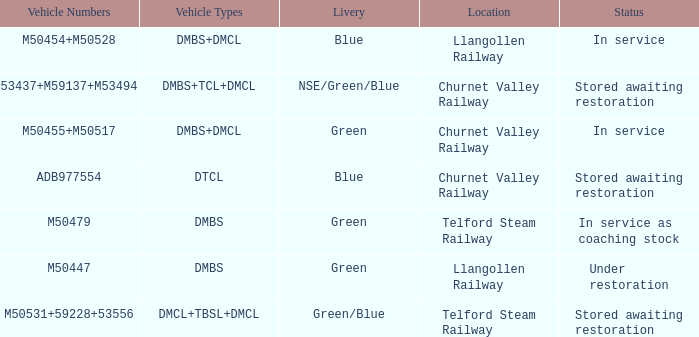What status is the vehicle numbers of adb977554? Stored awaiting restoration. 